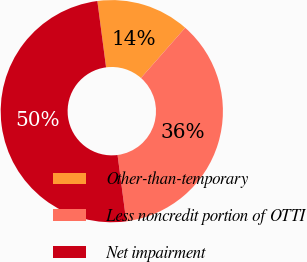Convert chart to OTSL. <chart><loc_0><loc_0><loc_500><loc_500><pie_chart><fcel>Other-than-temporary<fcel>Less noncredit portion of OTTI<fcel>Net impairment<nl><fcel>13.56%<fcel>36.44%<fcel>50.0%<nl></chart> 